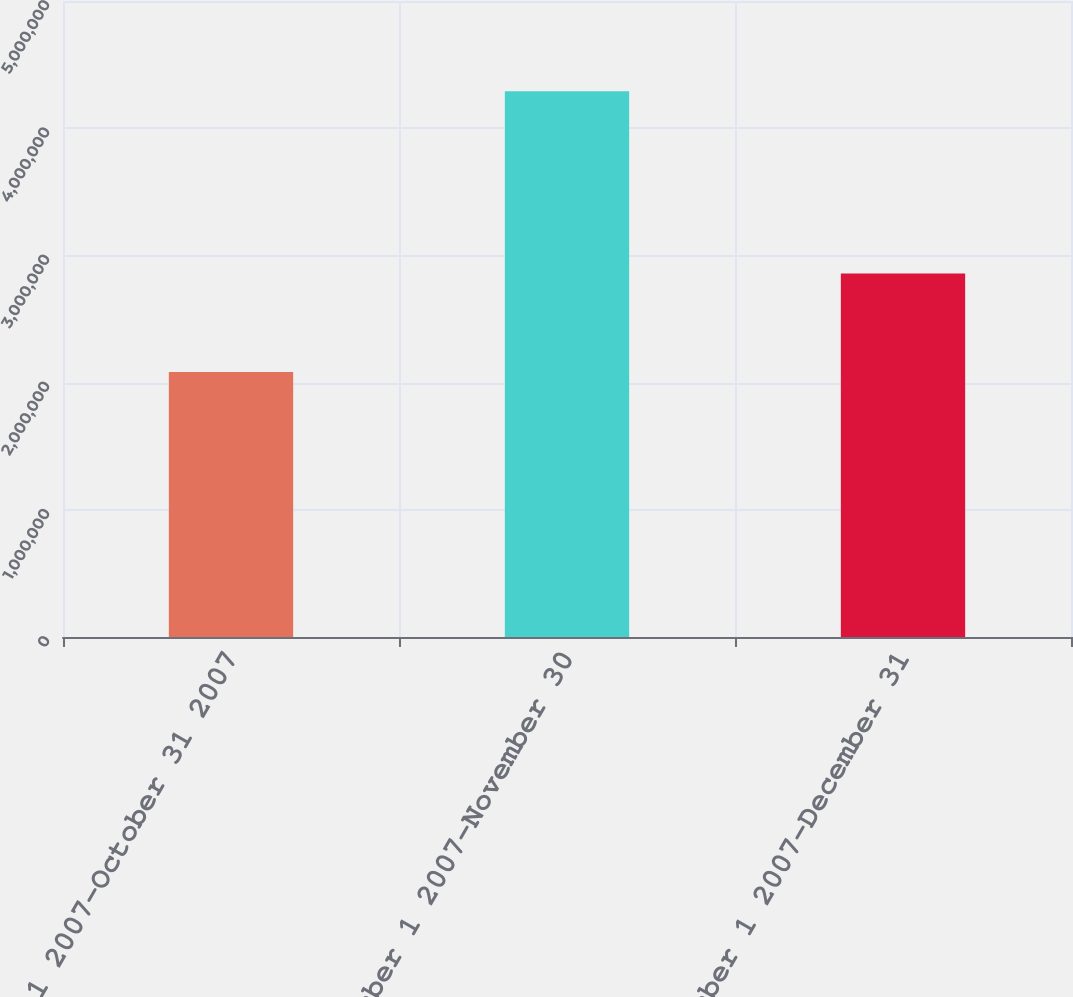<chart> <loc_0><loc_0><loc_500><loc_500><bar_chart><fcel>October 1 2007-October 31 2007<fcel>November 1 2007-November 30<fcel>December 1 2007-December 31<nl><fcel>2.083e+06<fcel>4.29085e+06<fcel>2.85714e+06<nl></chart> 